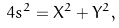<formula> <loc_0><loc_0><loc_500><loc_500>4 s ^ { 2 } = X ^ { 2 } + Y ^ { 2 } ,</formula> 